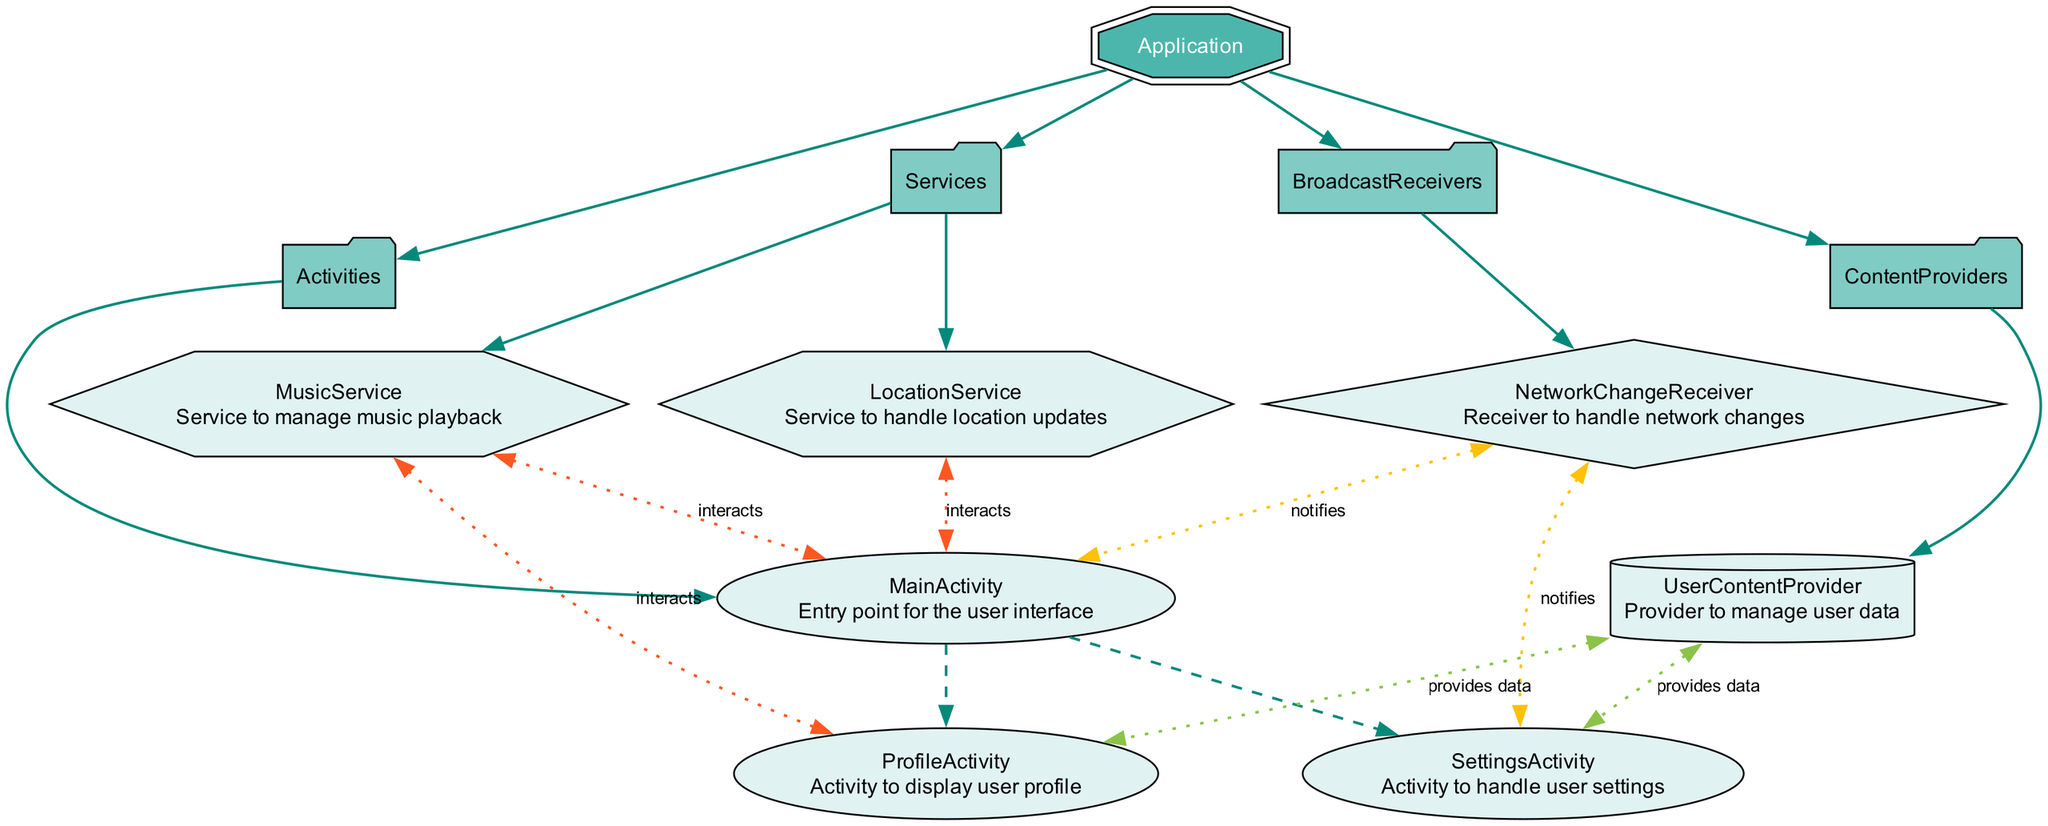What is the entry point for the user interface? The diagram shows that the "MainActivity" is the activity that serves as the entry point for the user interface, as indicated under the "Activities" section.
Answer: MainActivity How many services are listed in the diagram? The diagram contains two services: "LocationService" and "MusicService," as listed in the "Services" section under the "Application" node.
Answer: 2 Which activity handles user settings? The "SettingsActivity" is mentioned as the activity that handles user settings under the "MainActivity" as its child activity, making it the one responsible for this task.
Answer: SettingsActivity How does the "MusicService" interact with other components? The diagram indicates that "MusicService" interacts with both "MainActivity" and "ProfileActivity," as shown by the dotted edges linking them to the "MusicService" node, denoting interactions.
Answer: MainActivity, ProfileActivity What type of component is "UserContentProvider"? "UserContentProvider" is represented as a cylinder in the diagram, which signifies that it is a ContentProvider, categorized under the "ContentProviders" section of the hierarchy.
Answer: ContentProvider How many children does "MainActivity" have? The diagram shows that "MainActivity" has two children: "SettingsActivity" and "ProfileActivity." This can be seen under the "Activities" section where both children are connected to "MainActivity."
Answer: 2 Which broadcast receiver is responsible for handling network changes? The diagram specifies that the "NetworkChangeReceiver" is the broadcast receiver responsible for handling network changes, as indicated in the "BroadcastReceivers" section of the diagram.
Answer: NetworkChangeReceiver What is the relationship of "ProfileActivity" with "UserContentProvider"? The diagram shows that "ProfileActivity" interacts with "UserContentProvider," as indicated by the dotted edge connecting them, which denotes that "UserContentProvider" provides data for "ProfileActivity."
Answer: provides data Which activity is a child of "MainActivity"? The "ProfileActivity" is identified as one of the child activities of "MainActivity," as presented in the diagram's hierarchy under the "Activities" section.
Answer: ProfileActivity 